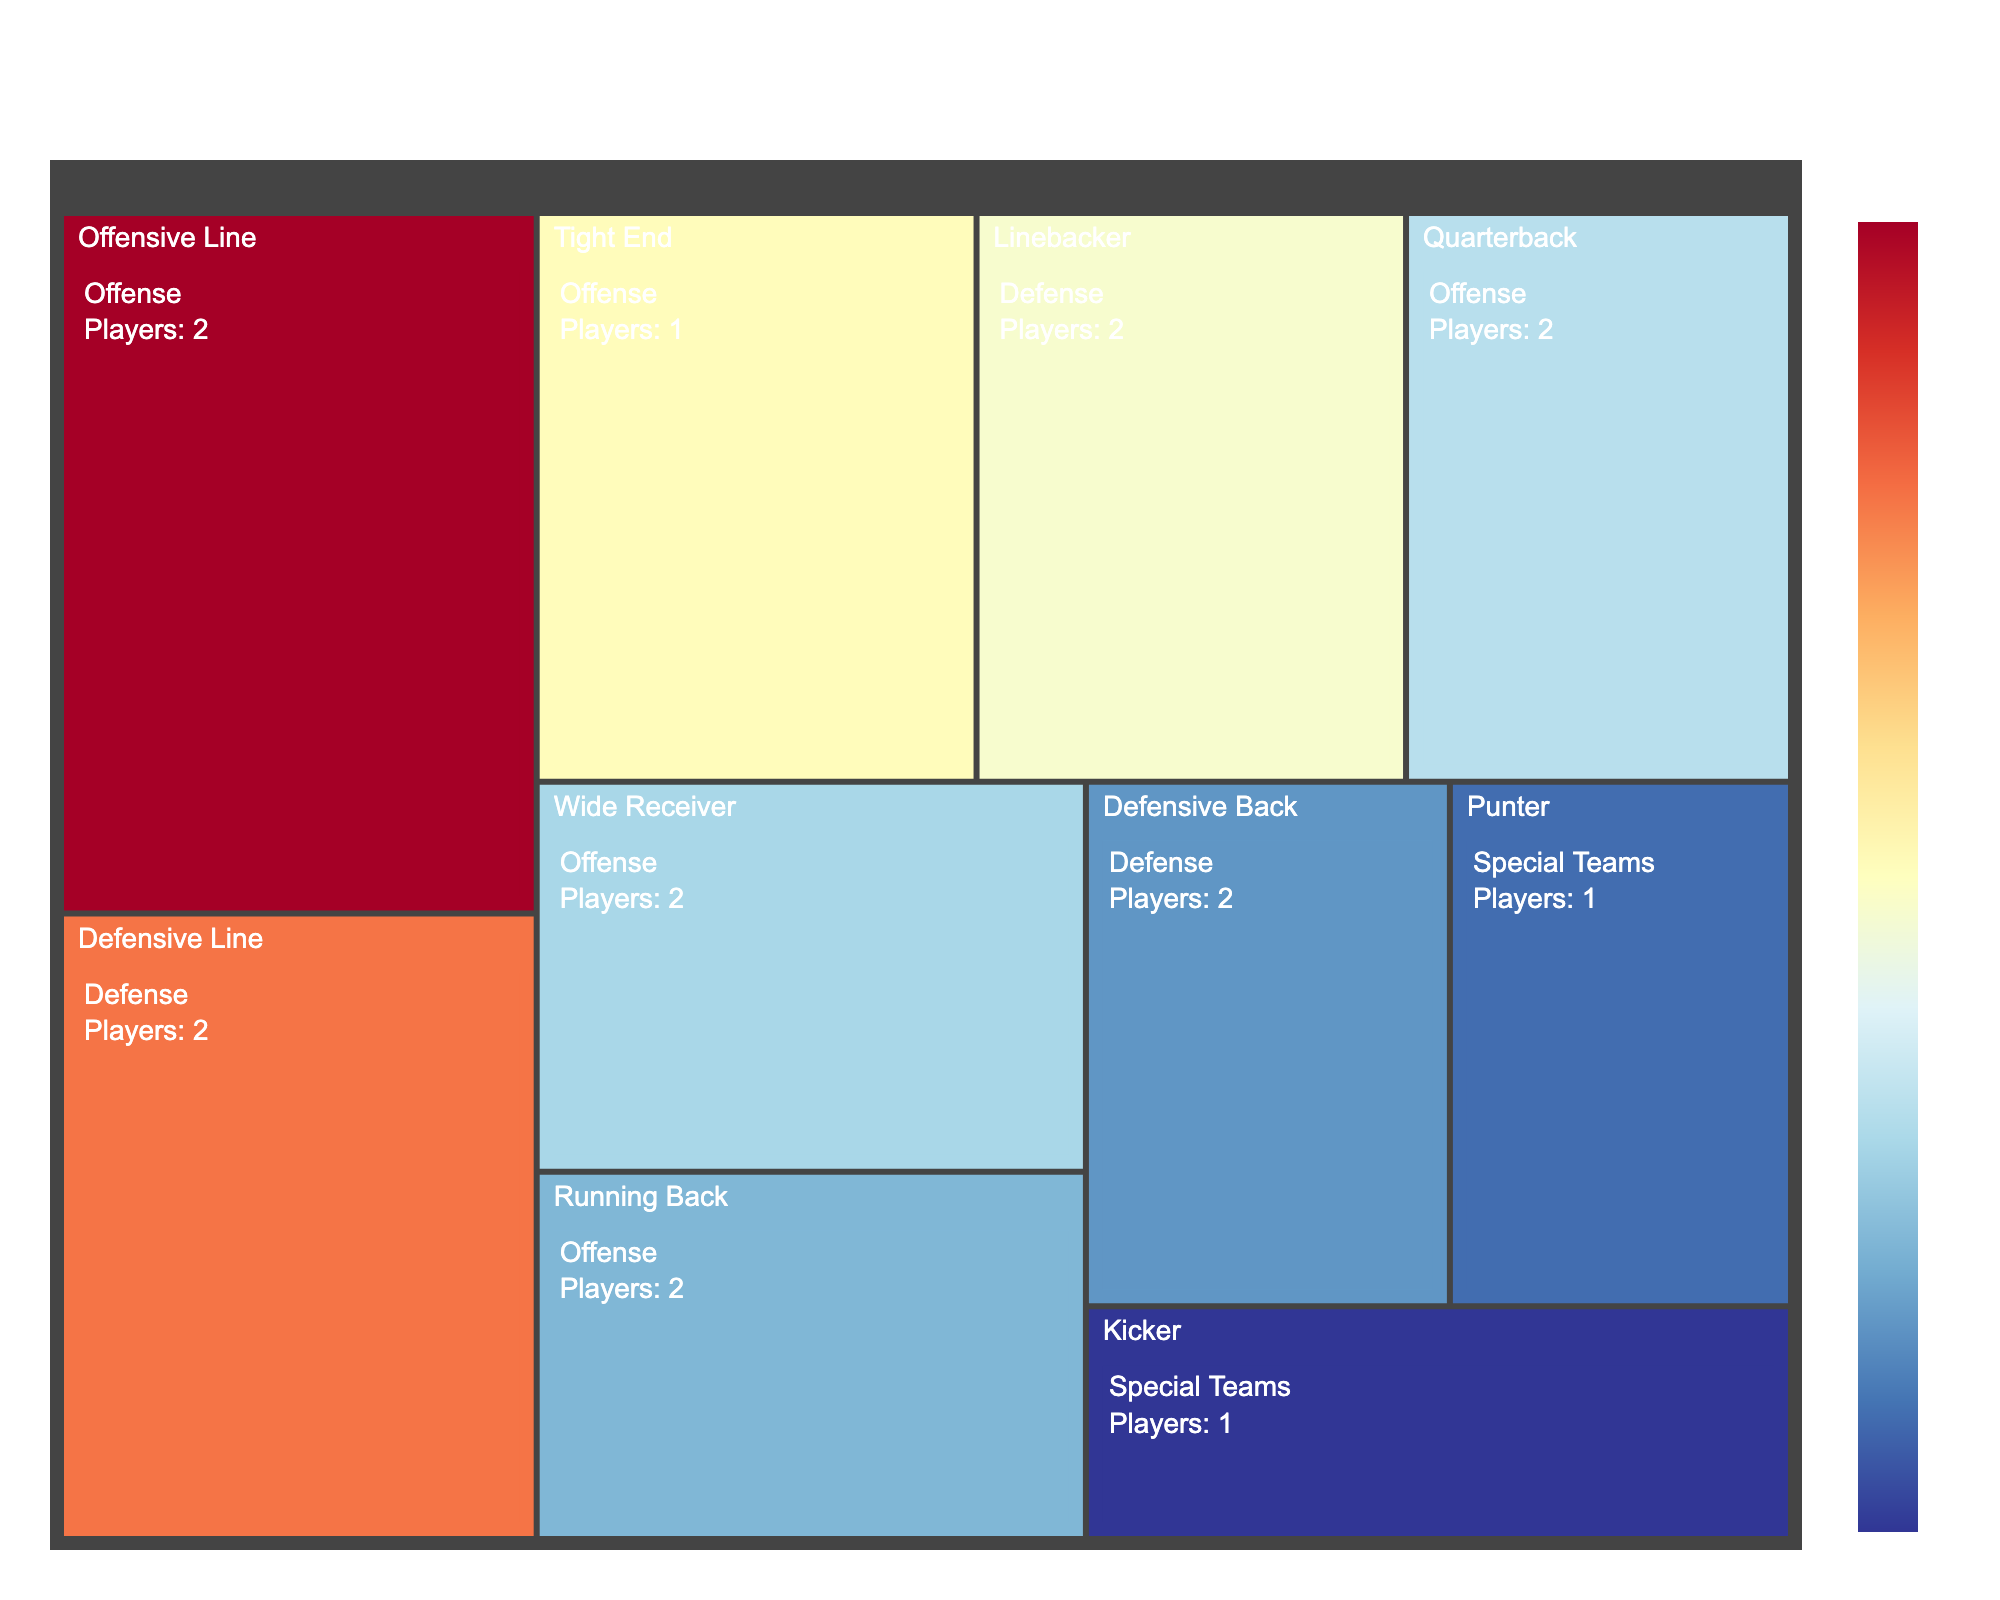What's the title of the treemap? The title is usually placed at the top center of the plot. It summarizes the main content or insight the plot provides.
Answer: NC State Wolfpack Football Team Composition How many position groups are represented in the plot? Look at the top-level divisions of the treemap which usually represent distinct categories or groups. Count them.
Answer: Three (Offense, Defense, Special Teams) Which specific position has the largest size index? Locate the largest rectangle in the treemap and refer to its label, which includes the position and number of players.
Answer: Offensive Line Which two positions have the smallest size indices? Identify the smallest rectangles in the treemap and read their labels.
Answer: Kicker and Punter Which group (Offense, Defense, Special Teams) has the highest combined size index? Sum the size indices of all positions within each group and compare the totals.
Answer: Offense Compare the size index of Quarterbacks and Linebackers. Which is greater? Look at the size indices represented by the rectangles for Quarterbacks and Linebackers and compare their values.
Answer: Linebackers How does the size index of Defensive Line compare to that of Wide Receiver? Examine the size indices of the rectangles labeled as Defensive Line and Wide Receiver, then compare them.
Answer: Defensive Line is larger What position groups do the colors in the treemap distinguish between? Notice how color is applied to differentiate groups. Pay attention to the legend or description of the color scheme.
Answer: The groups Offense, Defense, and Special Teams How many players are there in the Defense group? Sum the players indicated by the labels of all rectangles within the Defense section of the treemap.
Answer: 6 